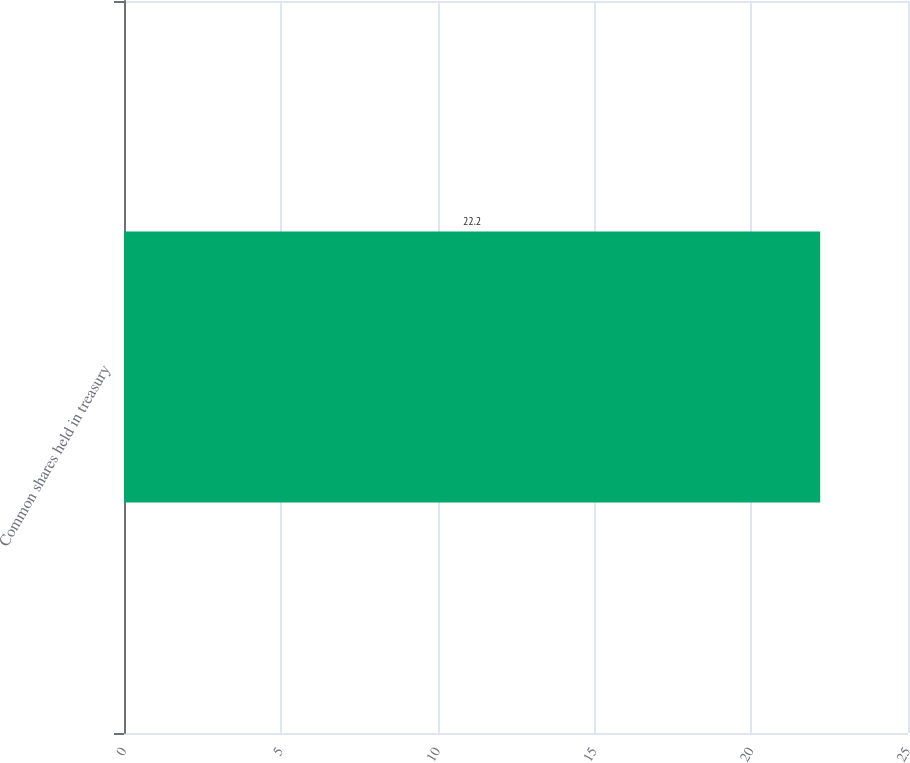Convert chart. <chart><loc_0><loc_0><loc_500><loc_500><bar_chart><fcel>Common shares held in treasury<nl><fcel>22.2<nl></chart> 